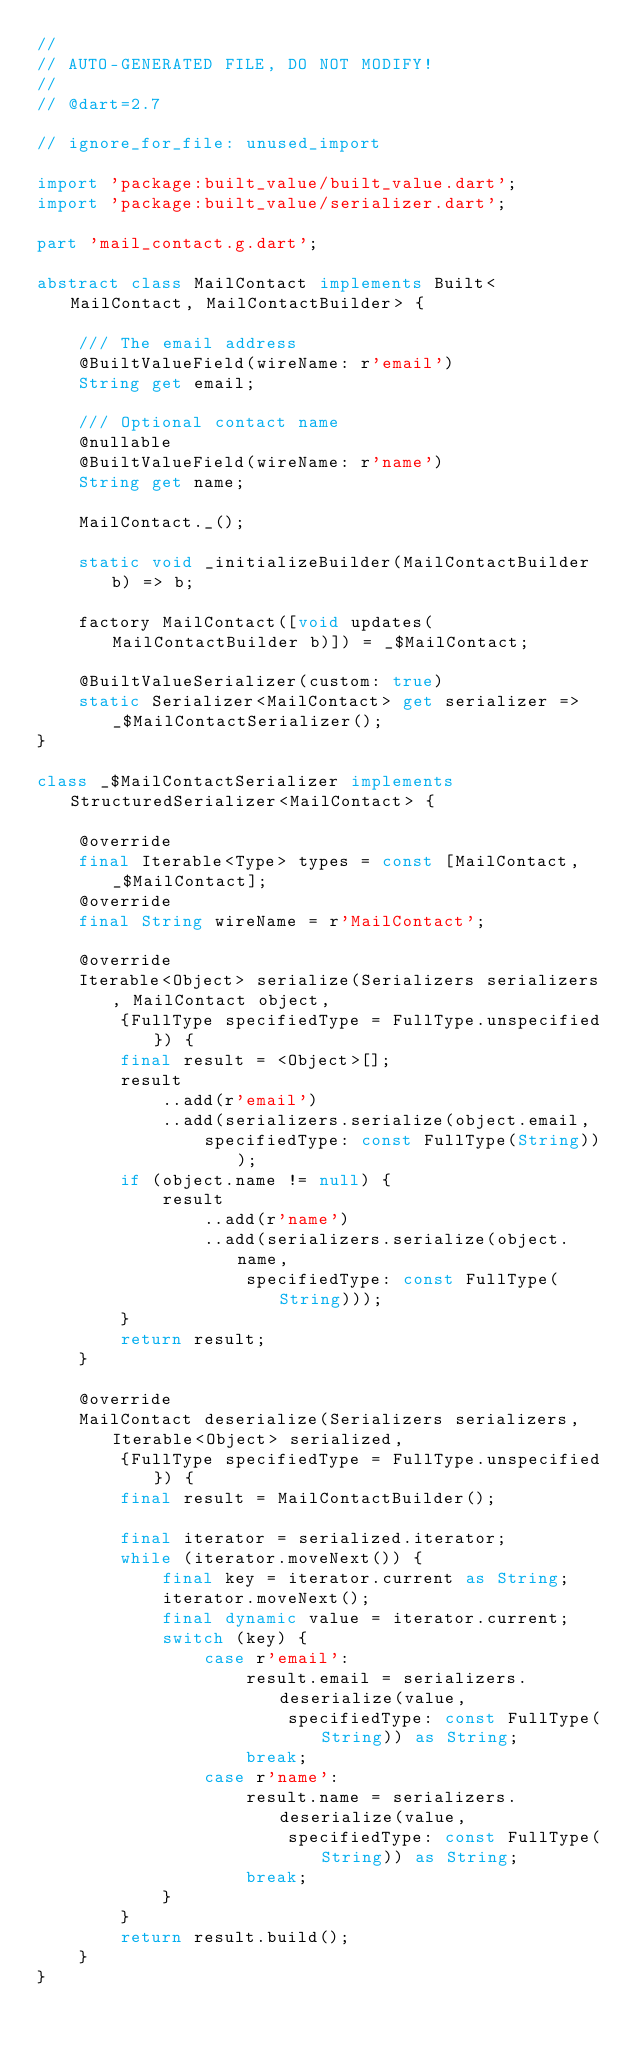<code> <loc_0><loc_0><loc_500><loc_500><_Dart_>//
// AUTO-GENERATED FILE, DO NOT MODIFY!
//
// @dart=2.7

// ignore_for_file: unused_import

import 'package:built_value/built_value.dart';
import 'package:built_value/serializer.dart';

part 'mail_contact.g.dart';

abstract class MailContact implements Built<MailContact, MailContactBuilder> {

    /// The email address
    @BuiltValueField(wireName: r'email')
    String get email;

    /// Optional contact name
    @nullable
    @BuiltValueField(wireName: r'name')
    String get name;

    MailContact._();

    static void _initializeBuilder(MailContactBuilder b) => b;

    factory MailContact([void updates(MailContactBuilder b)]) = _$MailContact;

    @BuiltValueSerializer(custom: true)
    static Serializer<MailContact> get serializer => _$MailContactSerializer();
}

class _$MailContactSerializer implements StructuredSerializer<MailContact> {

    @override
    final Iterable<Type> types = const [MailContact, _$MailContact];
    @override
    final String wireName = r'MailContact';

    @override
    Iterable<Object> serialize(Serializers serializers, MailContact object,
        {FullType specifiedType = FullType.unspecified}) {
        final result = <Object>[];
        result
            ..add(r'email')
            ..add(serializers.serialize(object.email,
                specifiedType: const FullType(String)));
        if (object.name != null) {
            result
                ..add(r'name')
                ..add(serializers.serialize(object.name,
                    specifiedType: const FullType(String)));
        }
        return result;
    }

    @override
    MailContact deserialize(Serializers serializers, Iterable<Object> serialized,
        {FullType specifiedType = FullType.unspecified}) {
        final result = MailContactBuilder();

        final iterator = serialized.iterator;
        while (iterator.moveNext()) {
            final key = iterator.current as String;
            iterator.moveNext();
            final dynamic value = iterator.current;
            switch (key) {
                case r'email':
                    result.email = serializers.deserialize(value,
                        specifiedType: const FullType(String)) as String;
                    break;
                case r'name':
                    result.name = serializers.deserialize(value,
                        specifiedType: const FullType(String)) as String;
                    break;
            }
        }
        return result.build();
    }
}

</code> 